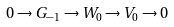Convert formula to latex. <formula><loc_0><loc_0><loc_500><loc_500>0 \to G _ { - 1 } \to W _ { 0 } \to V _ { 0 } \to 0</formula> 